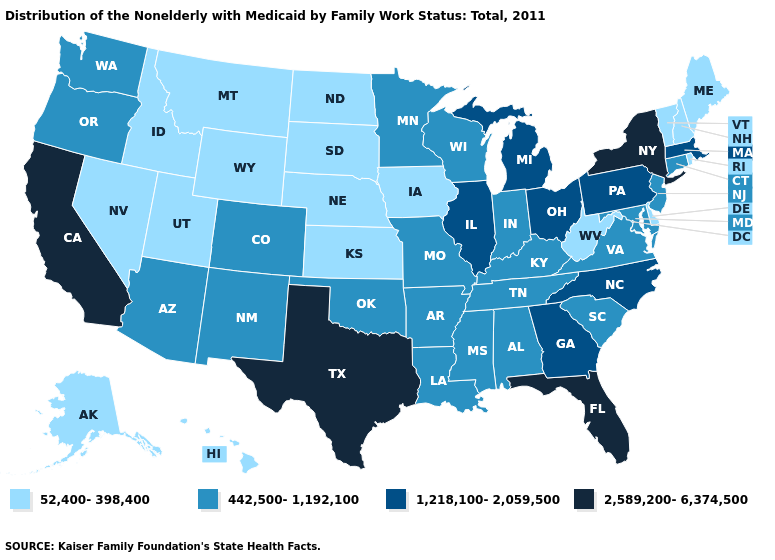Name the states that have a value in the range 52,400-398,400?
Quick response, please. Alaska, Delaware, Hawaii, Idaho, Iowa, Kansas, Maine, Montana, Nebraska, Nevada, New Hampshire, North Dakota, Rhode Island, South Dakota, Utah, Vermont, West Virginia, Wyoming. Does Massachusetts have the highest value in the USA?
Answer briefly. No. What is the value of Oregon?
Short answer required. 442,500-1,192,100. Name the states that have a value in the range 1,218,100-2,059,500?
Give a very brief answer. Georgia, Illinois, Massachusetts, Michigan, North Carolina, Ohio, Pennsylvania. What is the highest value in the MidWest ?
Answer briefly. 1,218,100-2,059,500. What is the highest value in the West ?
Concise answer only. 2,589,200-6,374,500. What is the highest value in the Northeast ?
Answer briefly. 2,589,200-6,374,500. Which states have the highest value in the USA?
Concise answer only. California, Florida, New York, Texas. Name the states that have a value in the range 52,400-398,400?
Write a very short answer. Alaska, Delaware, Hawaii, Idaho, Iowa, Kansas, Maine, Montana, Nebraska, Nevada, New Hampshire, North Dakota, Rhode Island, South Dakota, Utah, Vermont, West Virginia, Wyoming. Name the states that have a value in the range 2,589,200-6,374,500?
Give a very brief answer. California, Florida, New York, Texas. Does New York have the highest value in the USA?
Answer briefly. Yes. Which states have the lowest value in the USA?
Short answer required. Alaska, Delaware, Hawaii, Idaho, Iowa, Kansas, Maine, Montana, Nebraska, Nevada, New Hampshire, North Dakota, Rhode Island, South Dakota, Utah, Vermont, West Virginia, Wyoming. Does New York have the highest value in the Northeast?
Answer briefly. Yes. Does Virginia have the highest value in the USA?
Give a very brief answer. No. Does North Carolina have the same value as Pennsylvania?
Give a very brief answer. Yes. 